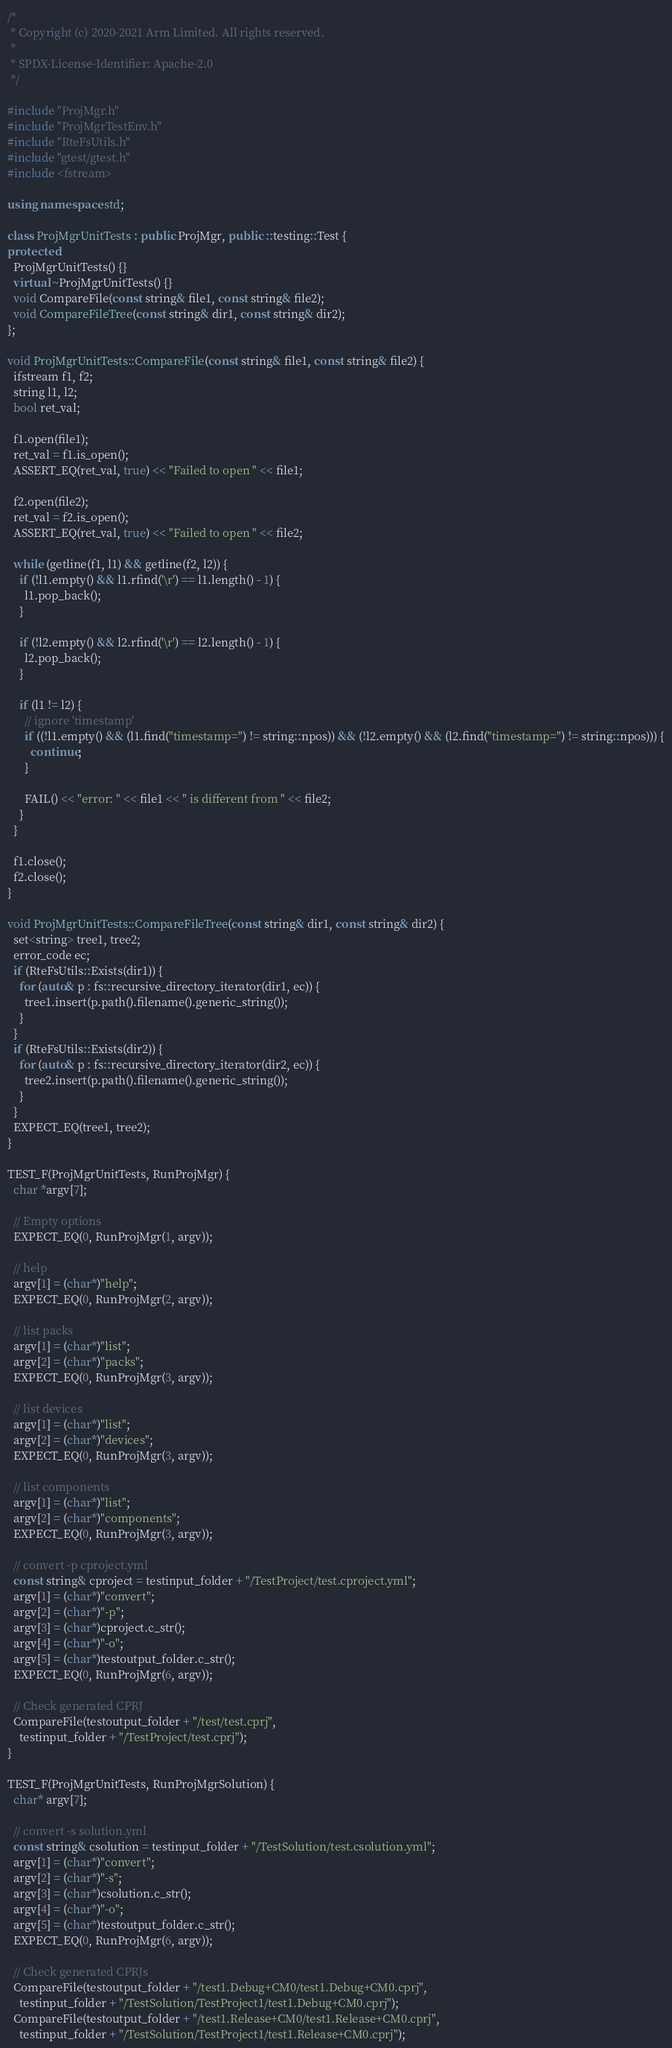Convert code to text. <code><loc_0><loc_0><loc_500><loc_500><_C++_>/*
 * Copyright (c) 2020-2021 Arm Limited. All rights reserved.
 *
 * SPDX-License-Identifier: Apache-2.0
 */

#include "ProjMgr.h"
#include "ProjMgrTestEnv.h"
#include "RteFsUtils.h"
#include "gtest/gtest.h"
#include <fstream>

using namespace std;

class ProjMgrUnitTests : public ProjMgr, public ::testing::Test {
protected:
  ProjMgrUnitTests() {}
  virtual ~ProjMgrUnitTests() {}
  void CompareFile(const string& file1, const string& file2);
  void CompareFileTree(const string& dir1, const string& dir2);
};

void ProjMgrUnitTests::CompareFile(const string& file1, const string& file2) {
  ifstream f1, f2;
  string l1, l2;
  bool ret_val;

  f1.open(file1);
  ret_val = f1.is_open();
  ASSERT_EQ(ret_val, true) << "Failed to open " << file1;

  f2.open(file2);
  ret_val = f2.is_open();
  ASSERT_EQ(ret_val, true) << "Failed to open " << file2;

  while (getline(f1, l1) && getline(f2, l2)) {
    if (!l1.empty() && l1.rfind('\r') == l1.length() - 1) {
      l1.pop_back();
    }

    if (!l2.empty() && l2.rfind('\r') == l2.length() - 1) {
      l2.pop_back();
    }

    if (l1 != l2) {
      // ignore 'timestamp'
      if ((!l1.empty() && (l1.find("timestamp=") != string::npos)) && (!l2.empty() && (l2.find("timestamp=") != string::npos))) {
        continue;
      }

      FAIL() << "error: " << file1 << " is different from " << file2;
    }
  }

  f1.close();
  f2.close();
}

void ProjMgrUnitTests::CompareFileTree(const string& dir1, const string& dir2) {
  set<string> tree1, tree2;
  error_code ec;
  if (RteFsUtils::Exists(dir1)) {
    for (auto& p : fs::recursive_directory_iterator(dir1, ec)) {
      tree1.insert(p.path().filename().generic_string());
    }
  }
  if (RteFsUtils::Exists(dir2)) {
    for (auto& p : fs::recursive_directory_iterator(dir2, ec)) {
      tree2.insert(p.path().filename().generic_string());
    }
  }
  EXPECT_EQ(tree1, tree2);
}

TEST_F(ProjMgrUnitTests, RunProjMgr) {
  char *argv[7];

  // Empty options
  EXPECT_EQ(0, RunProjMgr(1, argv));

  // help
  argv[1] = (char*)"help";
  EXPECT_EQ(0, RunProjMgr(2, argv));

  // list packs
  argv[1] = (char*)"list";
  argv[2] = (char*)"packs";
  EXPECT_EQ(0, RunProjMgr(3, argv));

  // list devices
  argv[1] = (char*)"list";
  argv[2] = (char*)"devices";
  EXPECT_EQ(0, RunProjMgr(3, argv));

  // list components
  argv[1] = (char*)"list";
  argv[2] = (char*)"components";
  EXPECT_EQ(0, RunProjMgr(3, argv));

  // convert -p cproject.yml
  const string& cproject = testinput_folder + "/TestProject/test.cproject.yml";
  argv[1] = (char*)"convert";
  argv[2] = (char*)"-p";
  argv[3] = (char*)cproject.c_str();
  argv[4] = (char*)"-o";
  argv[5] = (char*)testoutput_folder.c_str();
  EXPECT_EQ(0, RunProjMgr(6, argv));

  // Check generated CPRJ
  CompareFile(testoutput_folder + "/test/test.cprj",
    testinput_folder + "/TestProject/test.cprj");
}

TEST_F(ProjMgrUnitTests, RunProjMgrSolution) {
  char* argv[7];

  // convert -s solution.yml
  const string& csolution = testinput_folder + "/TestSolution/test.csolution.yml";
  argv[1] = (char*)"convert";
  argv[2] = (char*)"-s";
  argv[3] = (char*)csolution.c_str();
  argv[4] = (char*)"-o";
  argv[5] = (char*)testoutput_folder.c_str();
  EXPECT_EQ(0, RunProjMgr(6, argv));

  // Check generated CPRJs
  CompareFile(testoutput_folder + "/test1.Debug+CM0/test1.Debug+CM0.cprj",
    testinput_folder + "/TestSolution/TestProject1/test1.Debug+CM0.cprj");
  CompareFile(testoutput_folder + "/test1.Release+CM0/test1.Release+CM0.cprj",
    testinput_folder + "/TestSolution/TestProject1/test1.Release+CM0.cprj");
</code> 